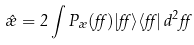<formula> <loc_0><loc_0><loc_500><loc_500>\hat { \rho } = 2 \int P _ { \rho } ( \alpha ) | \alpha \rangle \langle \alpha | \, d ^ { 2 } \alpha</formula> 